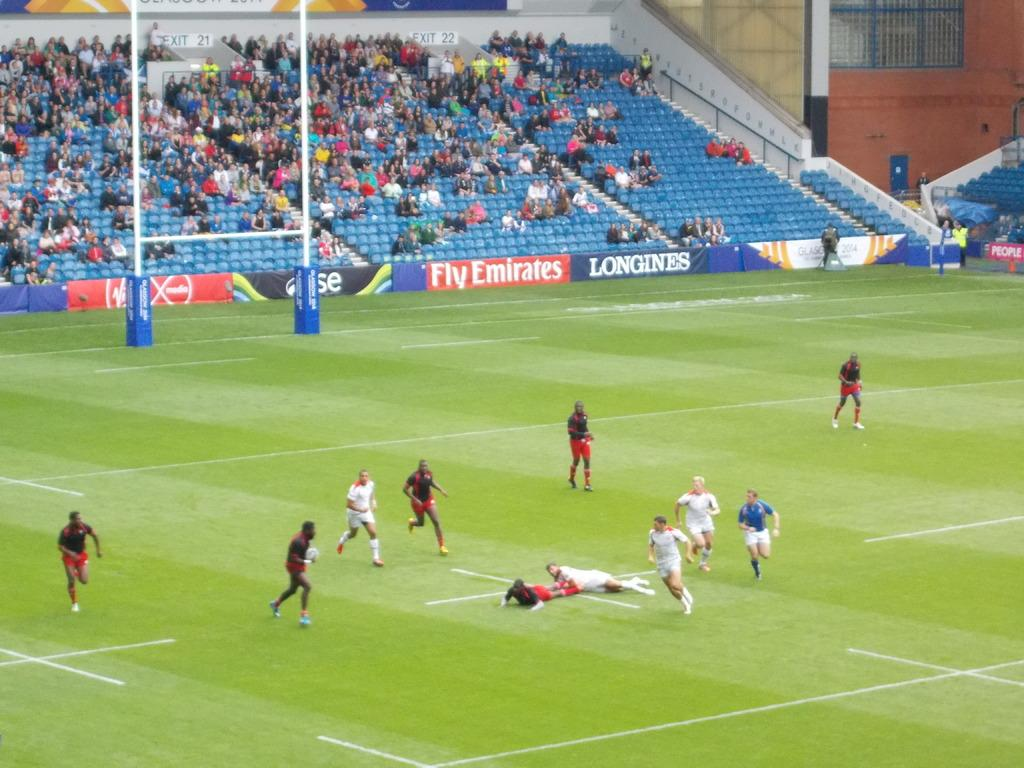What type of venue is shown in the image? The image depicts a soccer stadium. What activity is taking place in the stadium? People are playing a soccer game. Can you describe the people in the background? There are audience members sitting in the background. What structures can be seen in the background of the image? There are poles and hoardings visible in the background. What color is the orange being peeled by the bubble in the image? There is no orange or bubble present in the image. How is the chalk being used in the image? There is no chalk present in the image. 